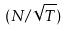<formula> <loc_0><loc_0><loc_500><loc_500>( N / \sqrt { T } )</formula> 